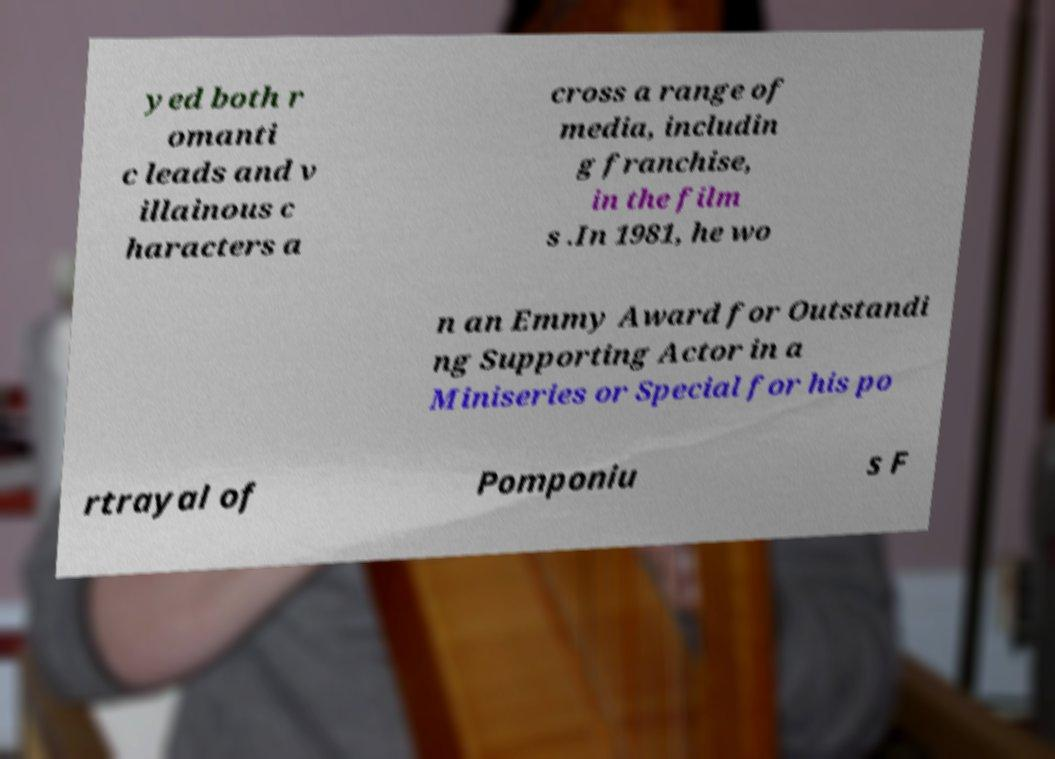There's text embedded in this image that I need extracted. Can you transcribe it verbatim? yed both r omanti c leads and v illainous c haracters a cross a range of media, includin g franchise, in the film s .In 1981, he wo n an Emmy Award for Outstandi ng Supporting Actor in a Miniseries or Special for his po rtrayal of Pomponiu s F 